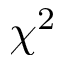Convert formula to latex. <formula><loc_0><loc_0><loc_500><loc_500>\chi ^ { 2 }</formula> 